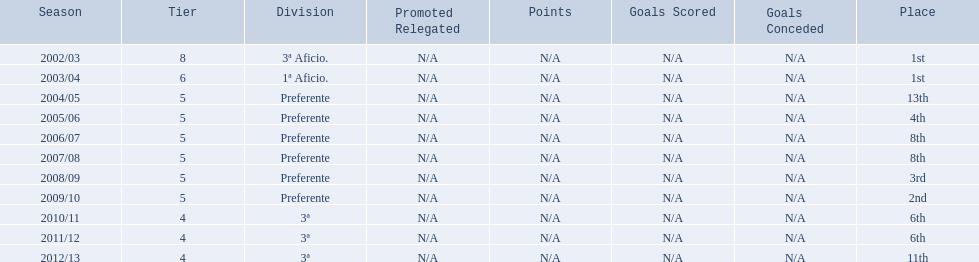Which seasons were played in tier four? 2010/11, 2011/12, 2012/13. Of these seasons, which resulted in 6th place? 2010/11, 2011/12. Which of the remaining happened last? 2011/12. 